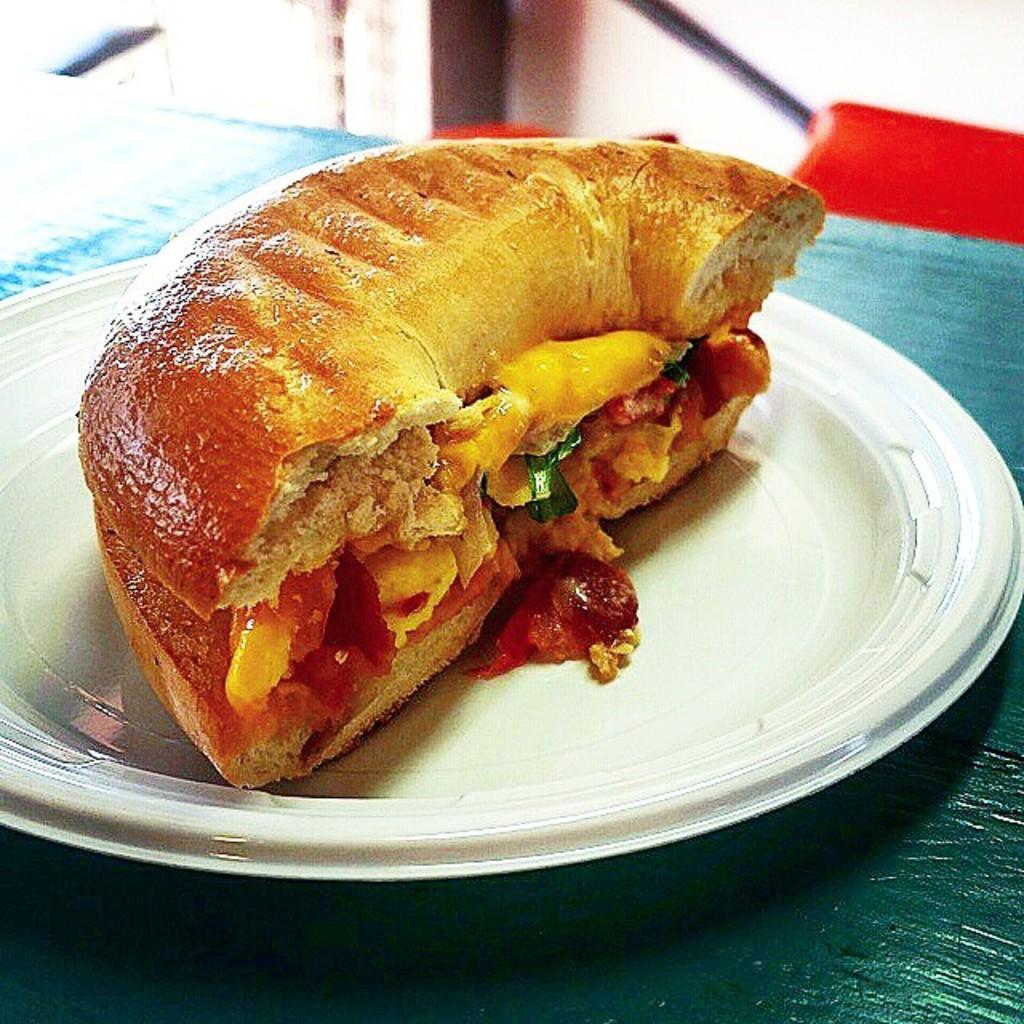Please provide a concise description of this image. In this image I can see the food in the plate and the food is in brown color and the plate is in white color. The plate is on the green color surface. 